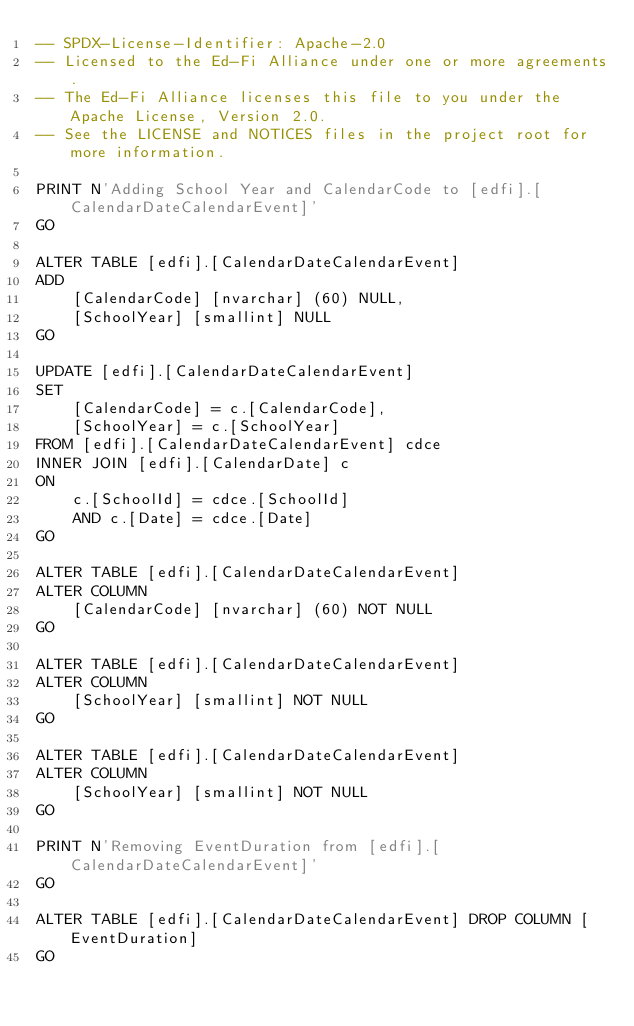Convert code to text. <code><loc_0><loc_0><loc_500><loc_500><_SQL_>-- SPDX-License-Identifier: Apache-2.0
-- Licensed to the Ed-Fi Alliance under one or more agreements.
-- The Ed-Fi Alliance licenses this file to you under the Apache License, Version 2.0.
-- See the LICENSE and NOTICES files in the project root for more information.

PRINT N'Adding School Year and CalendarCode to [edfi].[CalendarDateCalendarEvent]'
GO

ALTER TABLE [edfi].[CalendarDateCalendarEvent]
ADD 
	[CalendarCode] [nvarchar] (60) NULL,
	[SchoolYear] [smallint] NULL
GO

UPDATE [edfi].[CalendarDateCalendarEvent]
SET
	[CalendarCode] = c.[CalendarCode],
	[SchoolYear] = c.[SchoolYear]
FROM [edfi].[CalendarDateCalendarEvent] cdce
INNER JOIN [edfi].[CalendarDate] c
ON 
	c.[SchoolId] = cdce.[SchoolId]
	AND c.[Date] = cdce.[Date]
GO

ALTER TABLE [edfi].[CalendarDateCalendarEvent]
ALTER COLUMN
	[CalendarCode] [nvarchar] (60) NOT NULL
GO

ALTER TABLE [edfi].[CalendarDateCalendarEvent]
ALTER COLUMN
	[SchoolYear] [smallint] NOT NULL
GO

ALTER TABLE [edfi].[CalendarDateCalendarEvent]
ALTER COLUMN
	[SchoolYear] [smallint] NOT NULL
GO

PRINT N'Removing EventDuration from [edfi].[CalendarDateCalendarEvent]'
GO

ALTER TABLE [edfi].[CalendarDateCalendarEvent] DROP COLUMN [EventDuration]
GO
</code> 